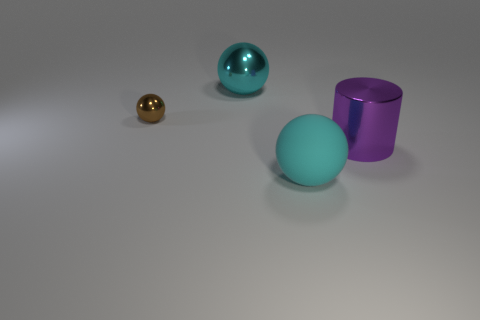There is a big metal thing that is on the right side of the big cyan object that is in front of the metallic thing that is on the right side of the rubber object; what is its shape?
Give a very brief answer. Cylinder. The metallic thing that is right of the big object to the left of the rubber thing is what shape?
Provide a short and direct response. Cylinder. Is there a purple object made of the same material as the tiny brown thing?
Provide a short and direct response. Yes. The metallic object that is the same color as the matte sphere is what size?
Your answer should be compact. Large. What number of gray things are either matte objects or small spheres?
Make the answer very short. 0. Are there any shiny things that have the same color as the big metal sphere?
Provide a short and direct response. No. The cyan sphere that is made of the same material as the large cylinder is what size?
Offer a terse response. Large. What number of cubes are large brown matte objects or shiny things?
Your answer should be very brief. 0. Is the number of cylinders greater than the number of big yellow rubber things?
Ensure brevity in your answer.  Yes. What number of other shiny things have the same size as the brown object?
Give a very brief answer. 0. 